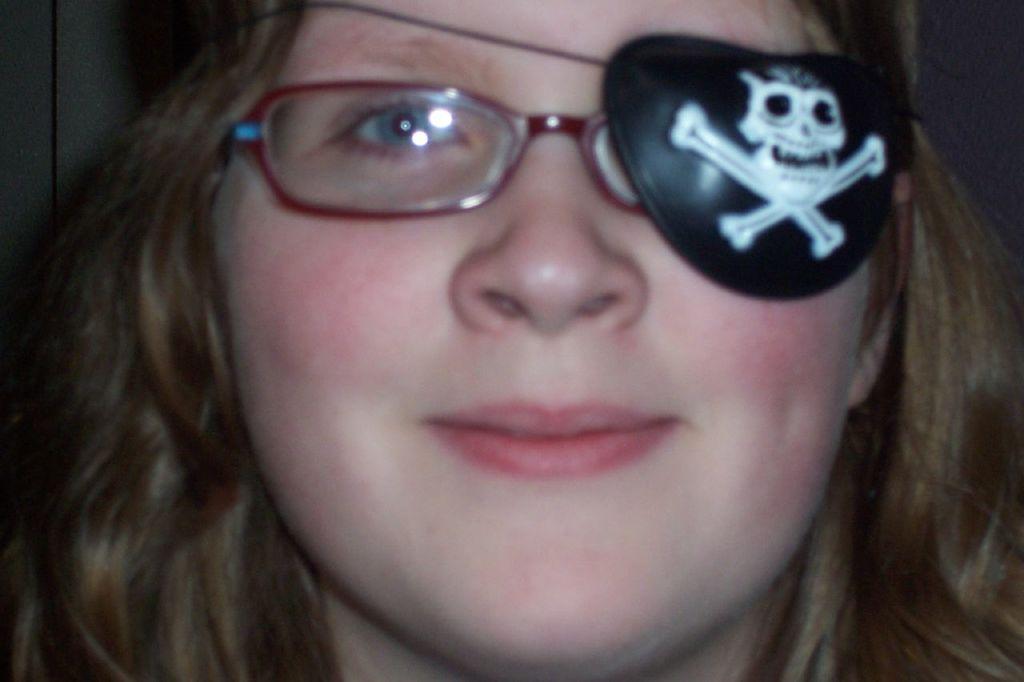Could you give a brief overview of what you see in this image? In the picture there is a woman and she is wearing spectacles,to her left eye there is a skull mask attached to the spectacle. 